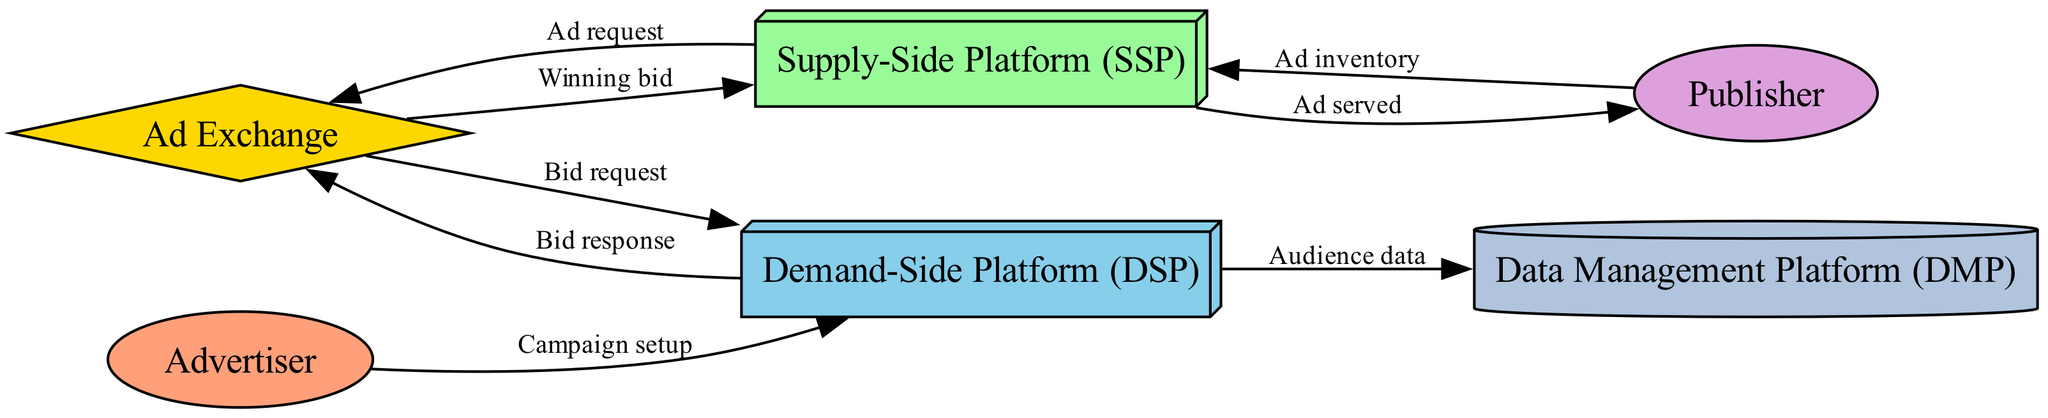What are the main components involved in the programmatic advertising system? The main components are Ad Exchange, Demand-Side Platform (DSP), Supply-Side Platform (SSP), Advertiser, Publisher, and Data Management Platform (DMP). These nodes represent crucial players in the real-time bidding process.
Answer: Ad Exchange, Demand-Side Platform (DSP), Supply-Side Platform (SSP), Advertiser, Publisher, Data Management Platform (DMP) How many nodes are present in the diagram? The diagram lists 6 nodes, which are distinct entities in the programmatic advertising system. Each node contributes to different functions in the real-time bidding process.
Answer: 6 What does the line from Publisher to SSP signify? The line indicates that the Publisher provides Ad inventory to the Supply-Side Platform, which serves as a mediator between the ad inventory and the demand from advertisers.
Answer: Ad inventory Which component receives the Bid request? The Bid request is received by the Demand-Side Platform (DSP), which is responsible for processing the bid based on audience data and predefined criteria.
Answer: Demand-Side Platform (DSP) What is the output of the SSP after receiving the Winning bid? After receiving the Winning bid, the SSP's output is serving the Ad to the Publisher, finalizing the transaction initiated by the bidding process.
Answer: Ad served What relationship does the Ad Exchange have with the Demand-Side Platform? The relationship is characterized by the Ad Exchange sending a Bid request to the Demand-Side Platform, where it seeks bids for available ad space.
Answer: Bid request How does the Demand-Side Platform utilize Audience data? The Demand-Side Platform uses Audience data to assess potential bidders and tailor bids based on the target demographics and interests for maximizing campaign effectiveness.
Answer: Audience data From which component does the Campaign setup originate? The Campaign setup originates from the Advertiser, who defines the parameters and goals for their advertising campaign to be executed via the Demand-Side Platform.
Answer: Advertiser 